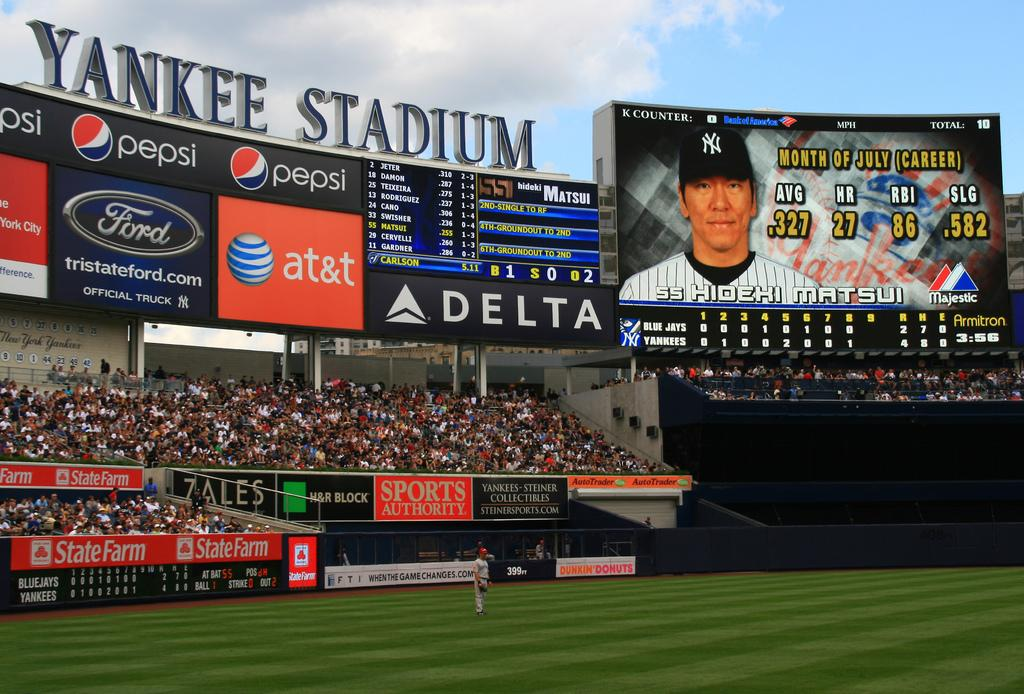<image>
Provide a brief description of the given image. Hadeki Matsui is shown the jumbtron during a game at Yankees stadium. 